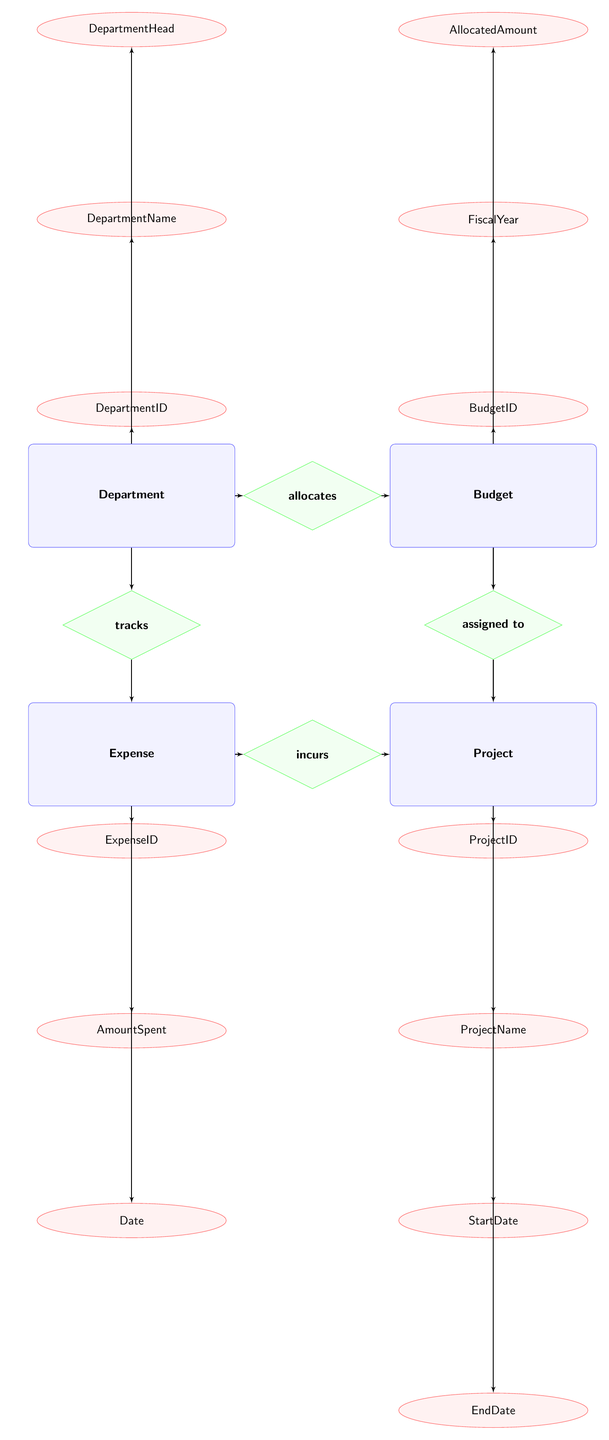What is the primary relationship between Department and Budget? The diagram shows an 'allocates' relationship between the Department and Budget entities. This indicates that a Department allocates funds to a specific Budget.
Answer: allocates How many attributes does the Expense entity have? The Expense entity includes three attributes: ExpenseID, AmountSpent, and Date. Counting these gives a total of three attributes.
Answer: 3 Which entity incurs expenses? From the diagram, the Expense entity shows an 'incurs' relationship toward the Project entity. This indicates that the Expense is related to projects that incur expenses.
Answer: Project What is the Department's primary head? The Department entity has one attribute called DepartmentHead. It does not specify a particular person's name in the diagram, but it would typically represent the individual responsible for overseeing the department.
Answer: DepartmentHead How many relationships connect the Budget entity? The Budget entity has two connections: 'allocates' to the Department and 'assigned to' to the Project. Adding these connections results in two relationships.
Answer: 2 Which entity tracks expenses? According to the diagram, the Department has a 'tracks' relationship with the Expense entity. This implies that the Department is responsible for tracking related expenses.
Answer: Expense What is the attribute representing the budget identifier? The Budget entity contains an attribute named BudgetID. This element uniquely identifies each budget within the entity.
Answer: BudgetID Which relationship connects Expense to Project? The Expense entity has an 'incurs' relationship toward the Project entity. This indicates that expenses are incurred by specific projects.
Answer: incurs What is the fiscal year attribute in the Budget entity? The Budget entity includes an attribute labeled FiscalYear, which designates the financial year for which the budget is allocated.
Answer: FiscalYear 